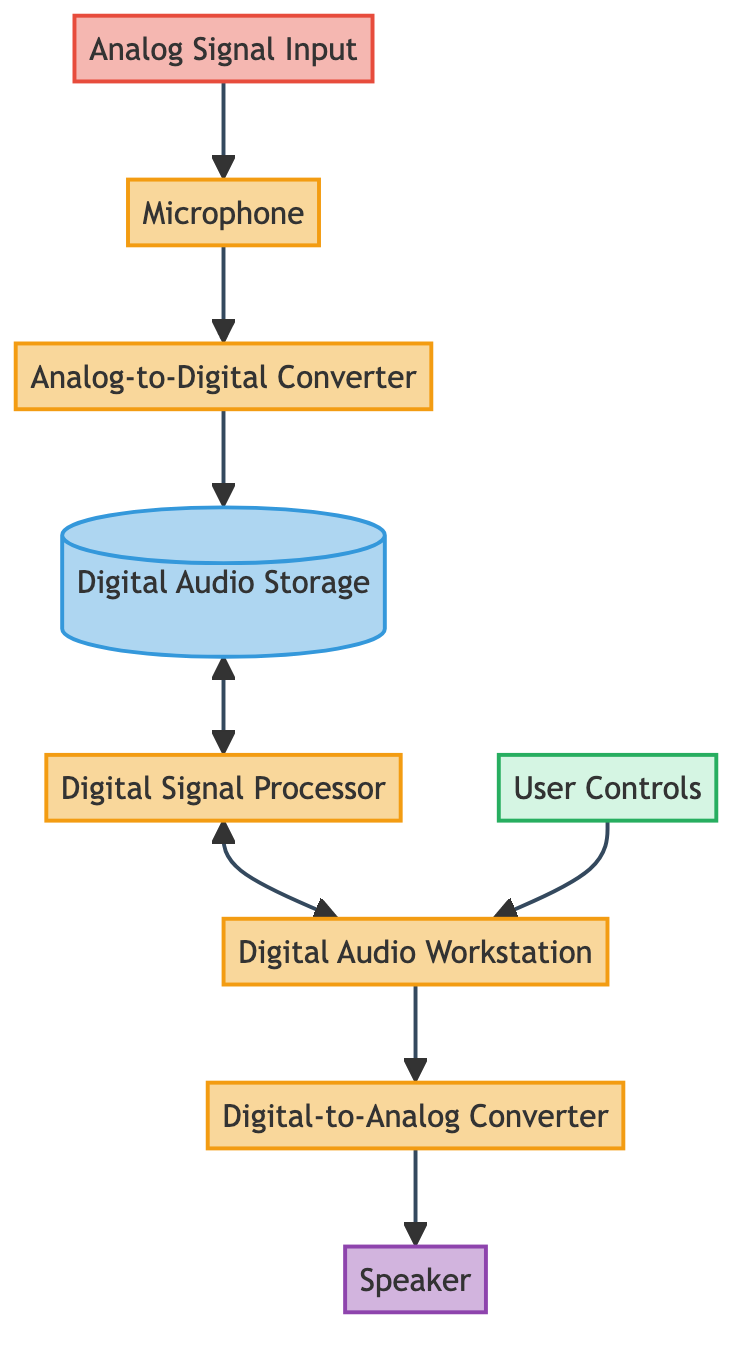What is the first node in the data flow? The first node in the data flow is labeled "Analog Signal Input." It is the source where sound waves are initially captured before processing.
Answer: Analog Signal Input How many processes are shown in the diagram? To determine the number of processes, we can identify the nodes labeled as processes: Microphone, Analog-to-Digital Converter, Digital Signal Processor, Digital Audio Workstation, and Digital-to-Analog Converter. Counting these gives us a total of five processes.
Answer: 5 What type of entity is "User Controls"? The "User Controls" node is classified as an external entity. This means it interacts with the process but is not part of the primary processing flow within the system.
Answer: external entity Which node stores the digital audio data? The node that stores the digital audio data is labeled "Digital Audio Storage." It is specifically designated for holding the digital representation of audio information until it is processed.
Answer: Digital Audio Storage What is the flow direction from Digital Signal Processor to Digital Audio Workstation? The flow direction from the Digital Signal Processor to the Digital Audio Workstation is bidirectional. This means data can move between these two nodes in both directions, facilitating manipulation and arrangement of audio data.
Answer: bidirectional How does the processed audio reach the user's speakers? The processed audio reaches the users' speakers by flowing from the Digital-to-Analog Converter to the Speaker node. The DAC converts the digital signals back into analog signals, which are then output as sound waves by the Speaker.
Answer: Digital-to-Analog Converter to Speaker What role does the Digital Signal Processor play in the diagram? The Digital Signal Processor's role in the diagram is to manipulate and process the stored digital audio data, allowing for actions like applying filters and effects to the audio.
Answer: Manipulates and processes In total, how many sources, processes, storage, entities, and sinks are depicted? By analyzing the diagram, we can categorize the nodes: one source (Analog Signal Input), five processes (Microphone, ADC, DSP, DAW, DAC), one storage (Digital Audio Storage), one entity (User Controls), and one sink (Speaker). This gives a total of eight nodes across these categories.
Answer: 1 source, 5 processes, 1 storage, 1 entity, 1 sink What is the flow relationship between Digital Audio Storage and Digital Signal Processor? The flow relationship between Digital Audio Storage and Digital Signal Processor is that they are interconnected with a two-way arrow, indicating that data can flow to and from each other. This facilitates the processing of audio data that is stored.
Answer: Two-way arrow (or bidirectional) 